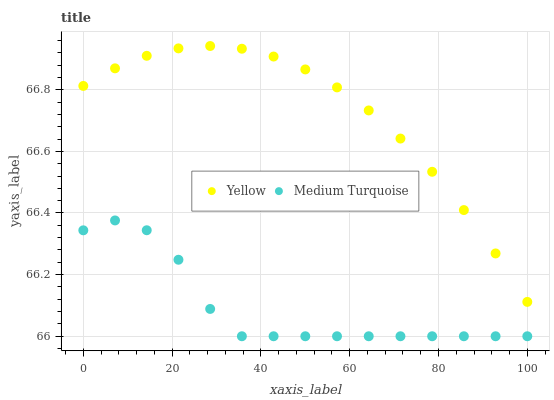Does Medium Turquoise have the minimum area under the curve?
Answer yes or no. Yes. Does Yellow have the maximum area under the curve?
Answer yes or no. Yes. Does Yellow have the minimum area under the curve?
Answer yes or no. No. Is Yellow the smoothest?
Answer yes or no. Yes. Is Medium Turquoise the roughest?
Answer yes or no. Yes. Is Yellow the roughest?
Answer yes or no. No. Does Medium Turquoise have the lowest value?
Answer yes or no. Yes. Does Yellow have the lowest value?
Answer yes or no. No. Does Yellow have the highest value?
Answer yes or no. Yes. Is Medium Turquoise less than Yellow?
Answer yes or no. Yes. Is Yellow greater than Medium Turquoise?
Answer yes or no. Yes. Does Medium Turquoise intersect Yellow?
Answer yes or no. No. 